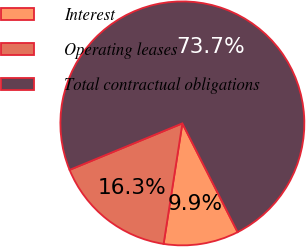<chart> <loc_0><loc_0><loc_500><loc_500><pie_chart><fcel>Interest<fcel>Operating leases<fcel>Total contractual obligations<nl><fcel>9.94%<fcel>16.32%<fcel>73.74%<nl></chart> 